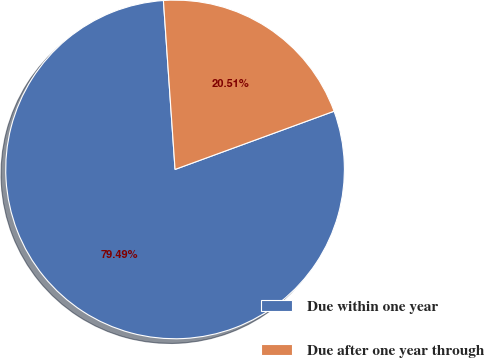<chart> <loc_0><loc_0><loc_500><loc_500><pie_chart><fcel>Due within one year<fcel>Due after one year through<nl><fcel>79.49%<fcel>20.51%<nl></chart> 